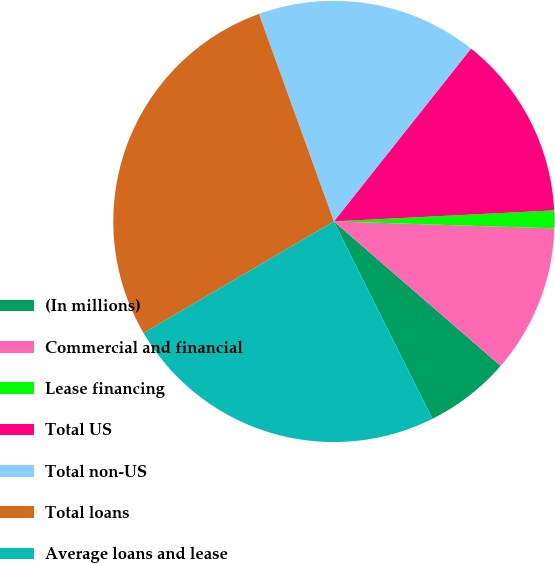<chart> <loc_0><loc_0><loc_500><loc_500><pie_chart><fcel>(In millions)<fcel>Commercial and financial<fcel>Lease financing<fcel>Total US<fcel>Total non-US<fcel>Total loans<fcel>Average loans and lease<nl><fcel>6.26%<fcel>10.86%<fcel>1.3%<fcel>13.53%<fcel>16.19%<fcel>27.92%<fcel>23.94%<nl></chart> 